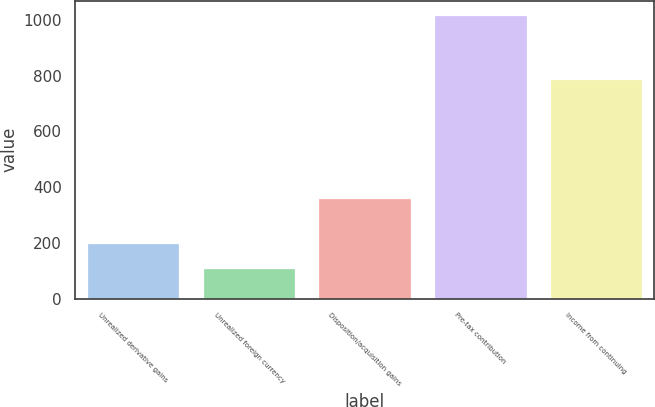Convert chart. <chart><loc_0><loc_0><loc_500><loc_500><bar_chart><fcel>Unrealized derivative gains<fcel>Unrealized foreign currency<fcel>Disposition/acquisition gains<fcel>Pre-tax contribution<fcel>Income from continuing<nl><fcel>200.7<fcel>110<fcel>361<fcel>1017<fcel>789<nl></chart> 